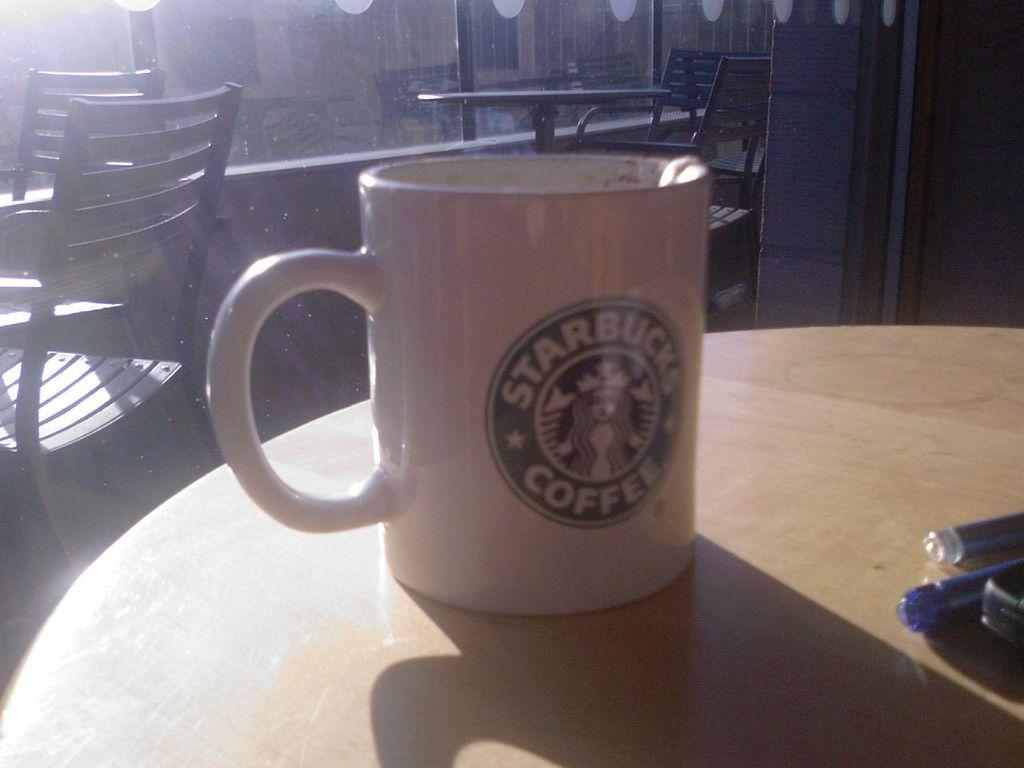What is one object that can be seen in the image? There is a cup in the image. What else can be seen in the image besides the cup? There are pens in the image. Can you describe the unspecified object on the table? Unfortunately, the facts provided do not specify the nature of the unspecified object on the table. What can be seen in the background of the image? In the background of the image, there are chairs, a table, a wall, and glass windows. What type of quill is being used to write on the jar in the image? There is no jar or quill present in the image. How many jars are visible in the image? There are no jars present in the image. 